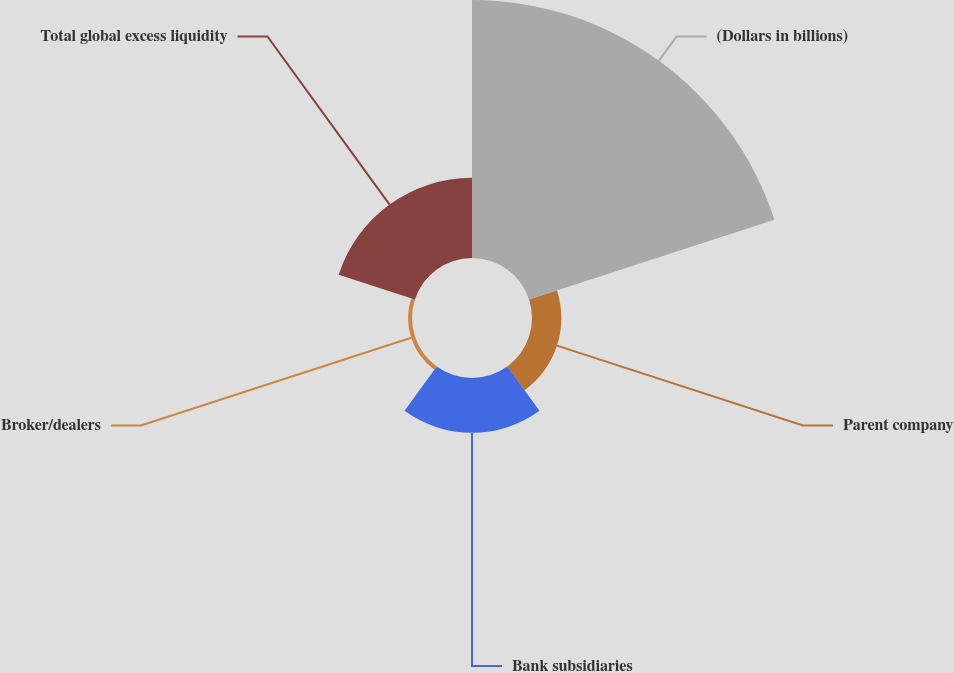Convert chart. <chart><loc_0><loc_0><loc_500><loc_500><pie_chart><fcel>(Dollars in billions)<fcel>Parent company<fcel>Bank subsidiaries<fcel>Broker/dealers<fcel>Total global excess liquidity<nl><fcel>60.52%<fcel>6.89%<fcel>12.85%<fcel>0.93%<fcel>18.81%<nl></chart> 